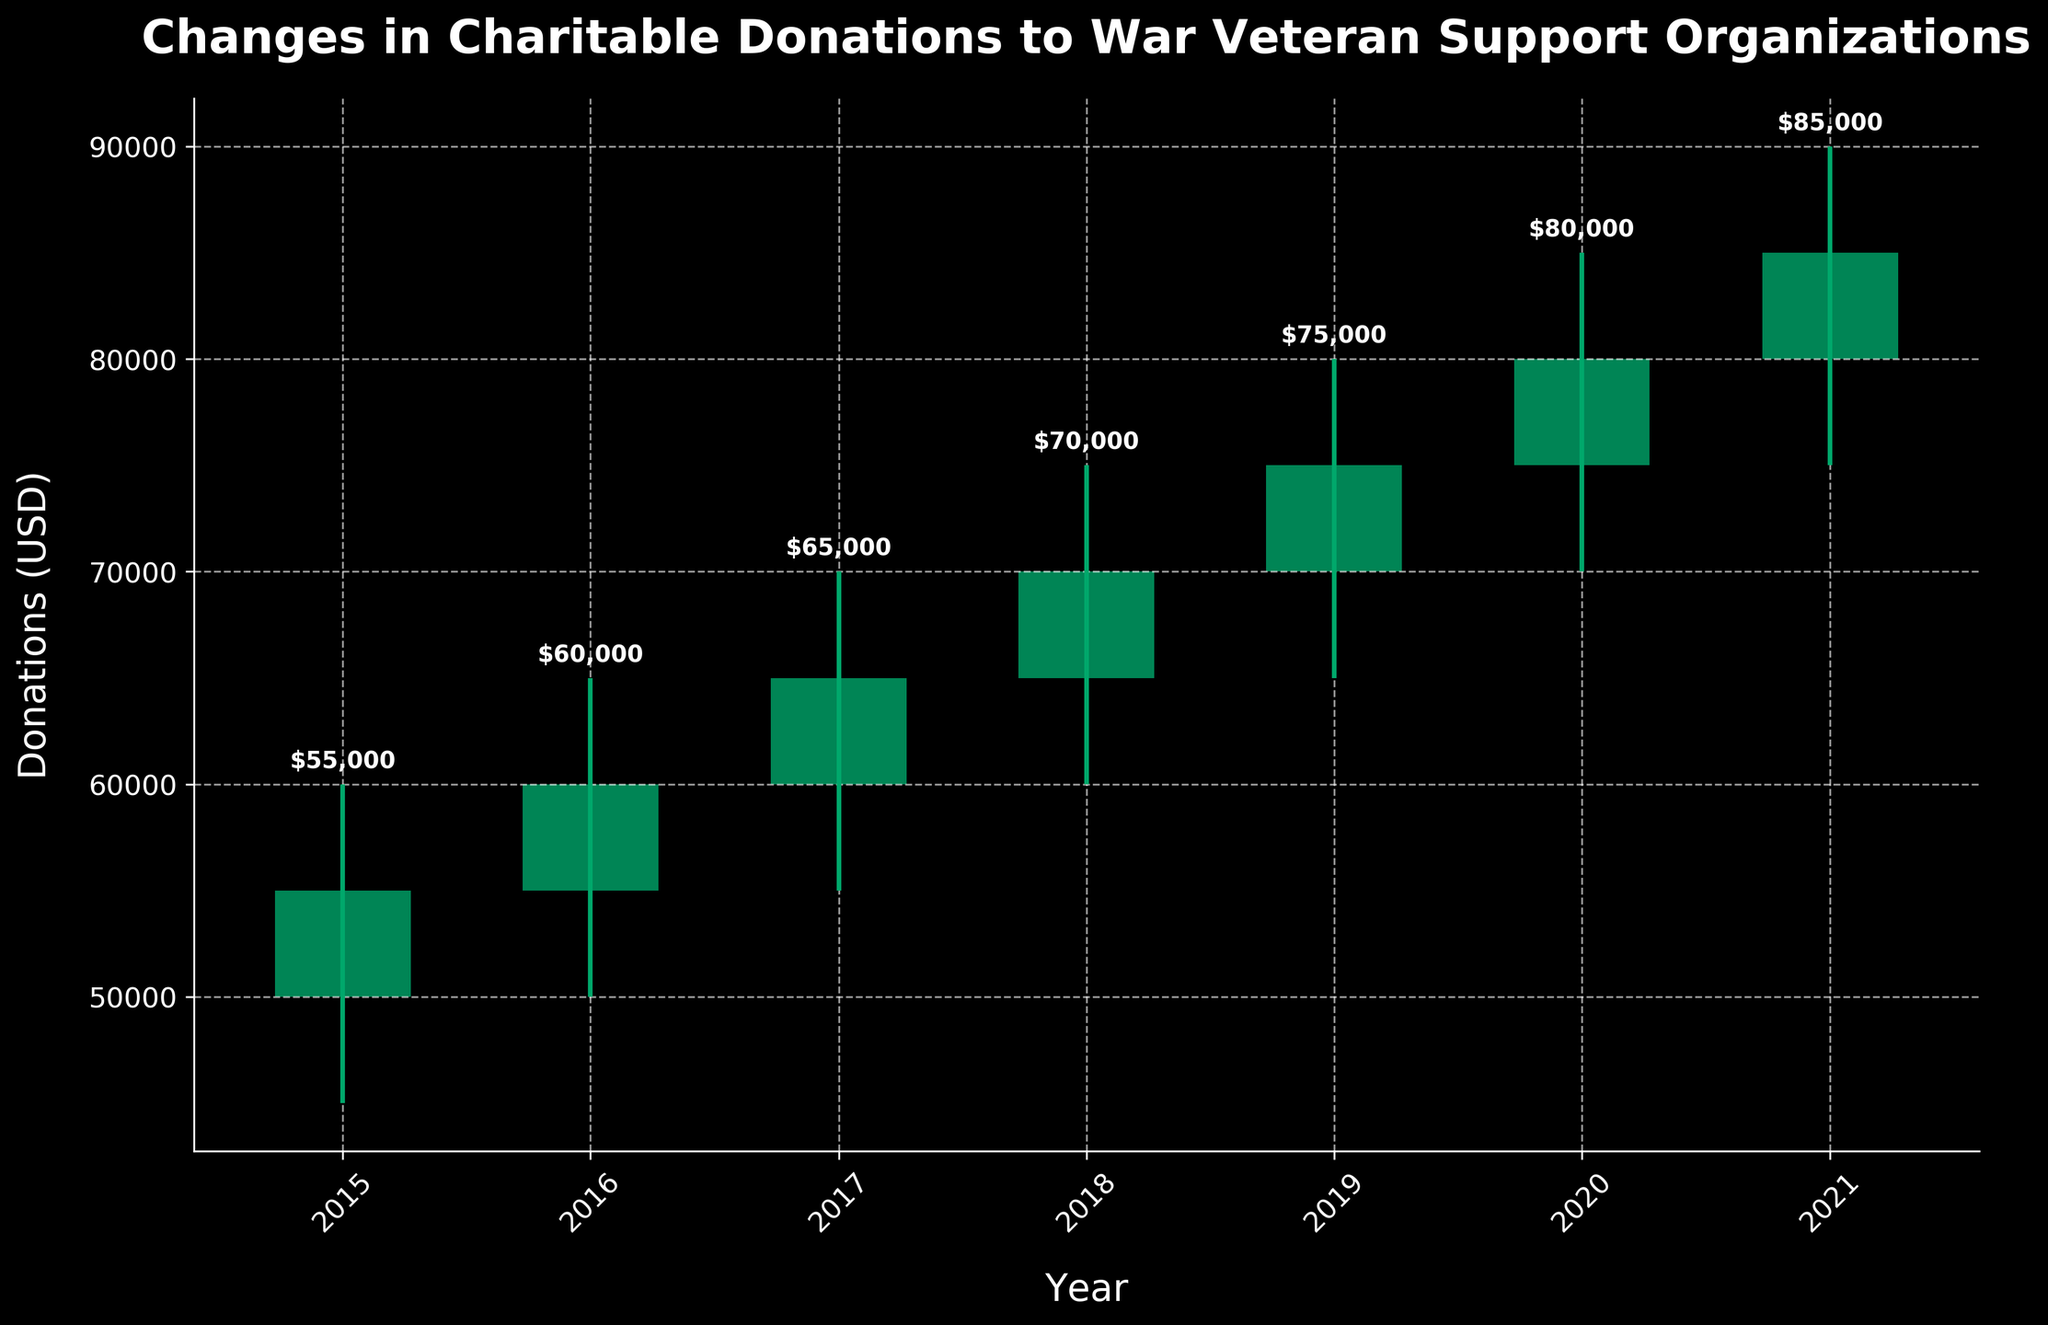What's the title of the plot? The title is located at the top of the plot, centered, usually in bold font to stand out.
Answer: Changes in Charitable Donations to War Veteran Support Organizations What is the total range of donations for the year 2019? The total range is calculated by subtracting the lowest donation value (Low) from the highest donation value (High) for 2019. Here, the range is: $80,000 - $65,000 = $15,000
Answer: $15,000 In which year did the highest donation at any point occur? To find the year with the highest donation at any point, look for the highest level on the chart across all years. In this case, it occurs at $90,000 in 2021.
Answer: 2021 What was the closing donation amount in 2017? The closing donation amount for 2017 is marked at the top of the candlestick body for that year, indicated by an annotation. The value is $65,000.
Answer: $65,000 In which year did the donations increase the most from the previous year? Calculate the difference between closing donations year-over-year to find the greatest increase. The differences are: 2016-2015: $5,000, 2017-2016: $5,000, 2018-2017: $5,000, 2019-2018: $5,000, 2020-2019: $5,000, 2021-2020: $5,000. Although all differences are equal, taking any one-year pair is sufficient.
Answer: 2021 How many years showed an increase in closing donations compared to the previous year? Count the number of years the closing donation is greater than the previous year's closing donation. All years (2016-2021) show an increase compared to their preceding year.
Answer: 6 Which year had the smallest difference between the high and low donation amounts? Compare the difference (High-Low) for each year: 2015: $15,000, 2016: $15,000, 2017: $15,000, 2018: $15,000, 2019: $15,000, 2020: $15,000, 2021: $15,000. The difference remains the same for all years.
Answer: 2015 to 2021 (all years) Was there any year where the donations at closing were less than at opening? Observe the color of the candlestick's bodies. Red bodies indicate closing values lower than opening values. Here, no red bodies are present, suggesting there were no years with lower closing donations.
Answer: No Describe the trend in the closing donation amounts from 2015 to 2021. Look at the closing values year by year to observe the trend. They increased consistently from 2015 ($55,000) to 2021 ($85,000) without any drops.
Answer: Increasing trend 